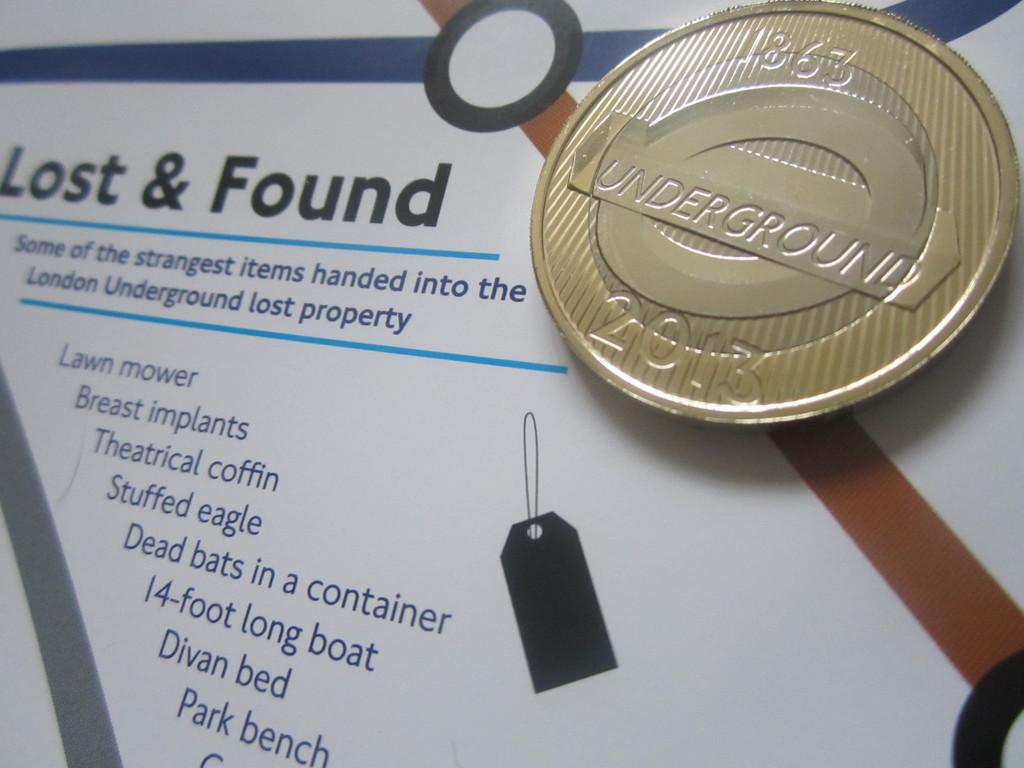What is the lost and found for?
Keep it short and to the point. Answering does not require reading text in the image. What year is on the coin?
Provide a short and direct response. 2013. 